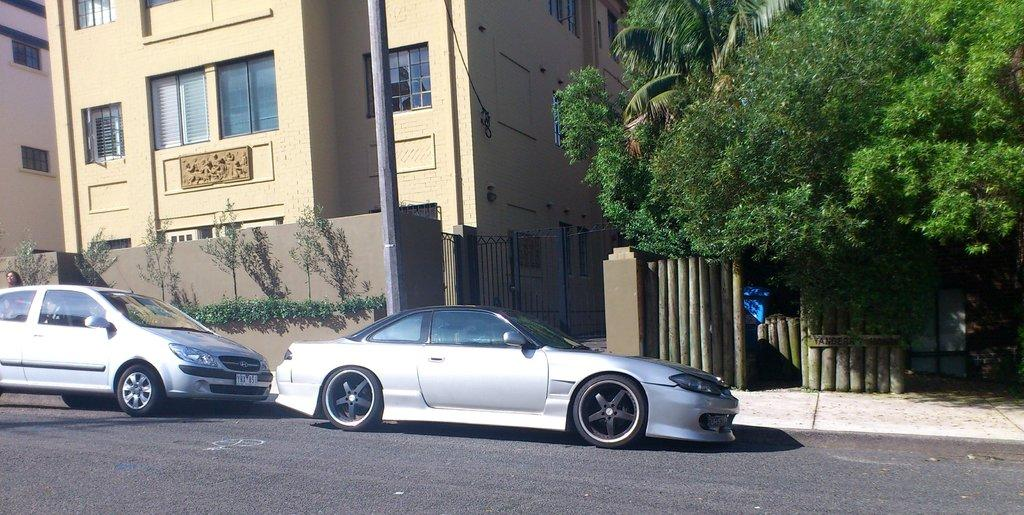What can be seen on the road in the image? There are cars on the road in the image. What is visible in the background of the image? There are buildings and trees in the background of the image. Can you describe the vegetation in front of a building in the image? There are plants in front of a building in the image. What object can be seen standing upright in the image? There is a pole in the image. Can you see a monkey playing baseball on the road in the image? There is no monkey playing baseball on the road in the image. What type of airplane is flying above the buildings in the image? There is no airplane visible in the image. 